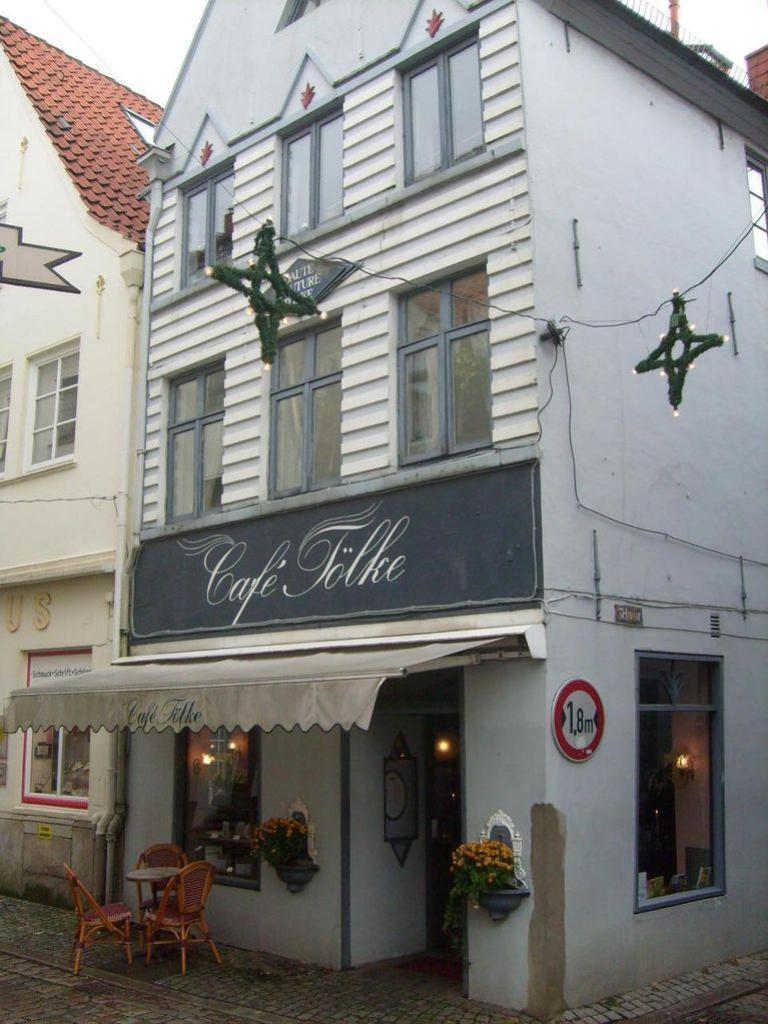What type of structure is visible in the image? There is a building in the image. What type of furniture is present in the image? There are chairs in the image. What other object can be seen in the image besides the chairs? There is a table in the image. How many wrens are perched on the table in the image? There are no wrens present in the image. What type of lift is used to transport people in the building in the image? The image does not show any lifts or indicate the presence of a lift in the building. 